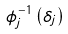<formula> <loc_0><loc_0><loc_500><loc_500>\phi _ { j } ^ { - 1 } \left ( \delta _ { j } \right )</formula> 